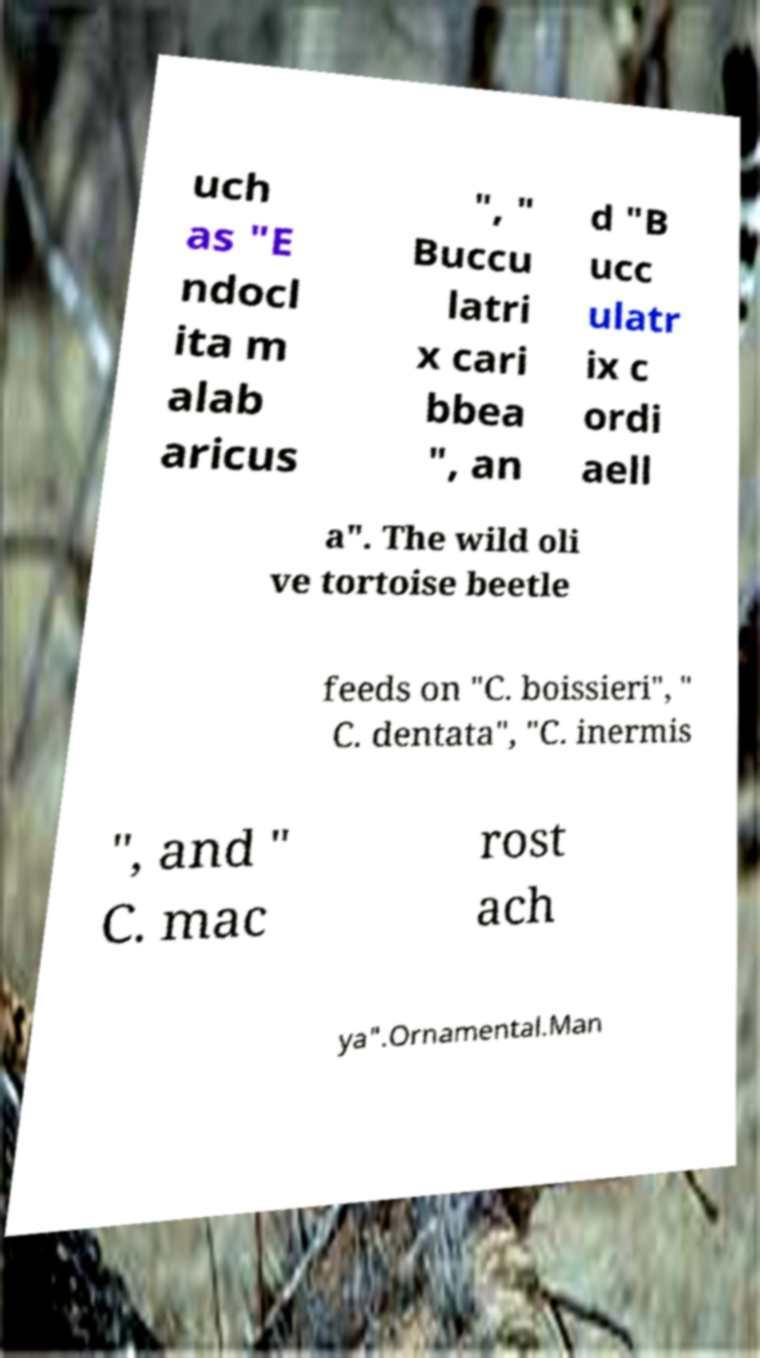There's text embedded in this image that I need extracted. Can you transcribe it verbatim? uch as "E ndocl ita m alab aricus ", " Buccu latri x cari bbea ", an d "B ucc ulatr ix c ordi aell a". The wild oli ve tortoise beetle feeds on "C. boissieri", " C. dentata", "C. inermis ", and " C. mac rost ach ya".Ornamental.Man 